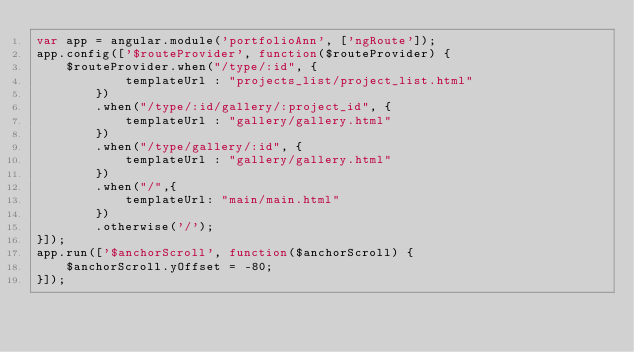Convert code to text. <code><loc_0><loc_0><loc_500><loc_500><_JavaScript_>var app = angular.module('portfolioAnn', ['ngRoute']);
app.config(['$routeProvider', function($routeProvider) {
    $routeProvider.when("/type/:id", {
            templateUrl : "projects_list/project_list.html"
        })
        .when("/type/:id/gallery/:project_id", {
            templateUrl : "gallery/gallery.html"
        })
        .when("/type/gallery/:id", {
            templateUrl : "gallery/gallery.html"
        })
        .when("/",{
            templateUrl: "main/main.html"
        })
        .otherwise('/');
}]);
app.run(['$anchorScroll', function($anchorScroll) {
    $anchorScroll.yOffset = -80;
}]);</code> 